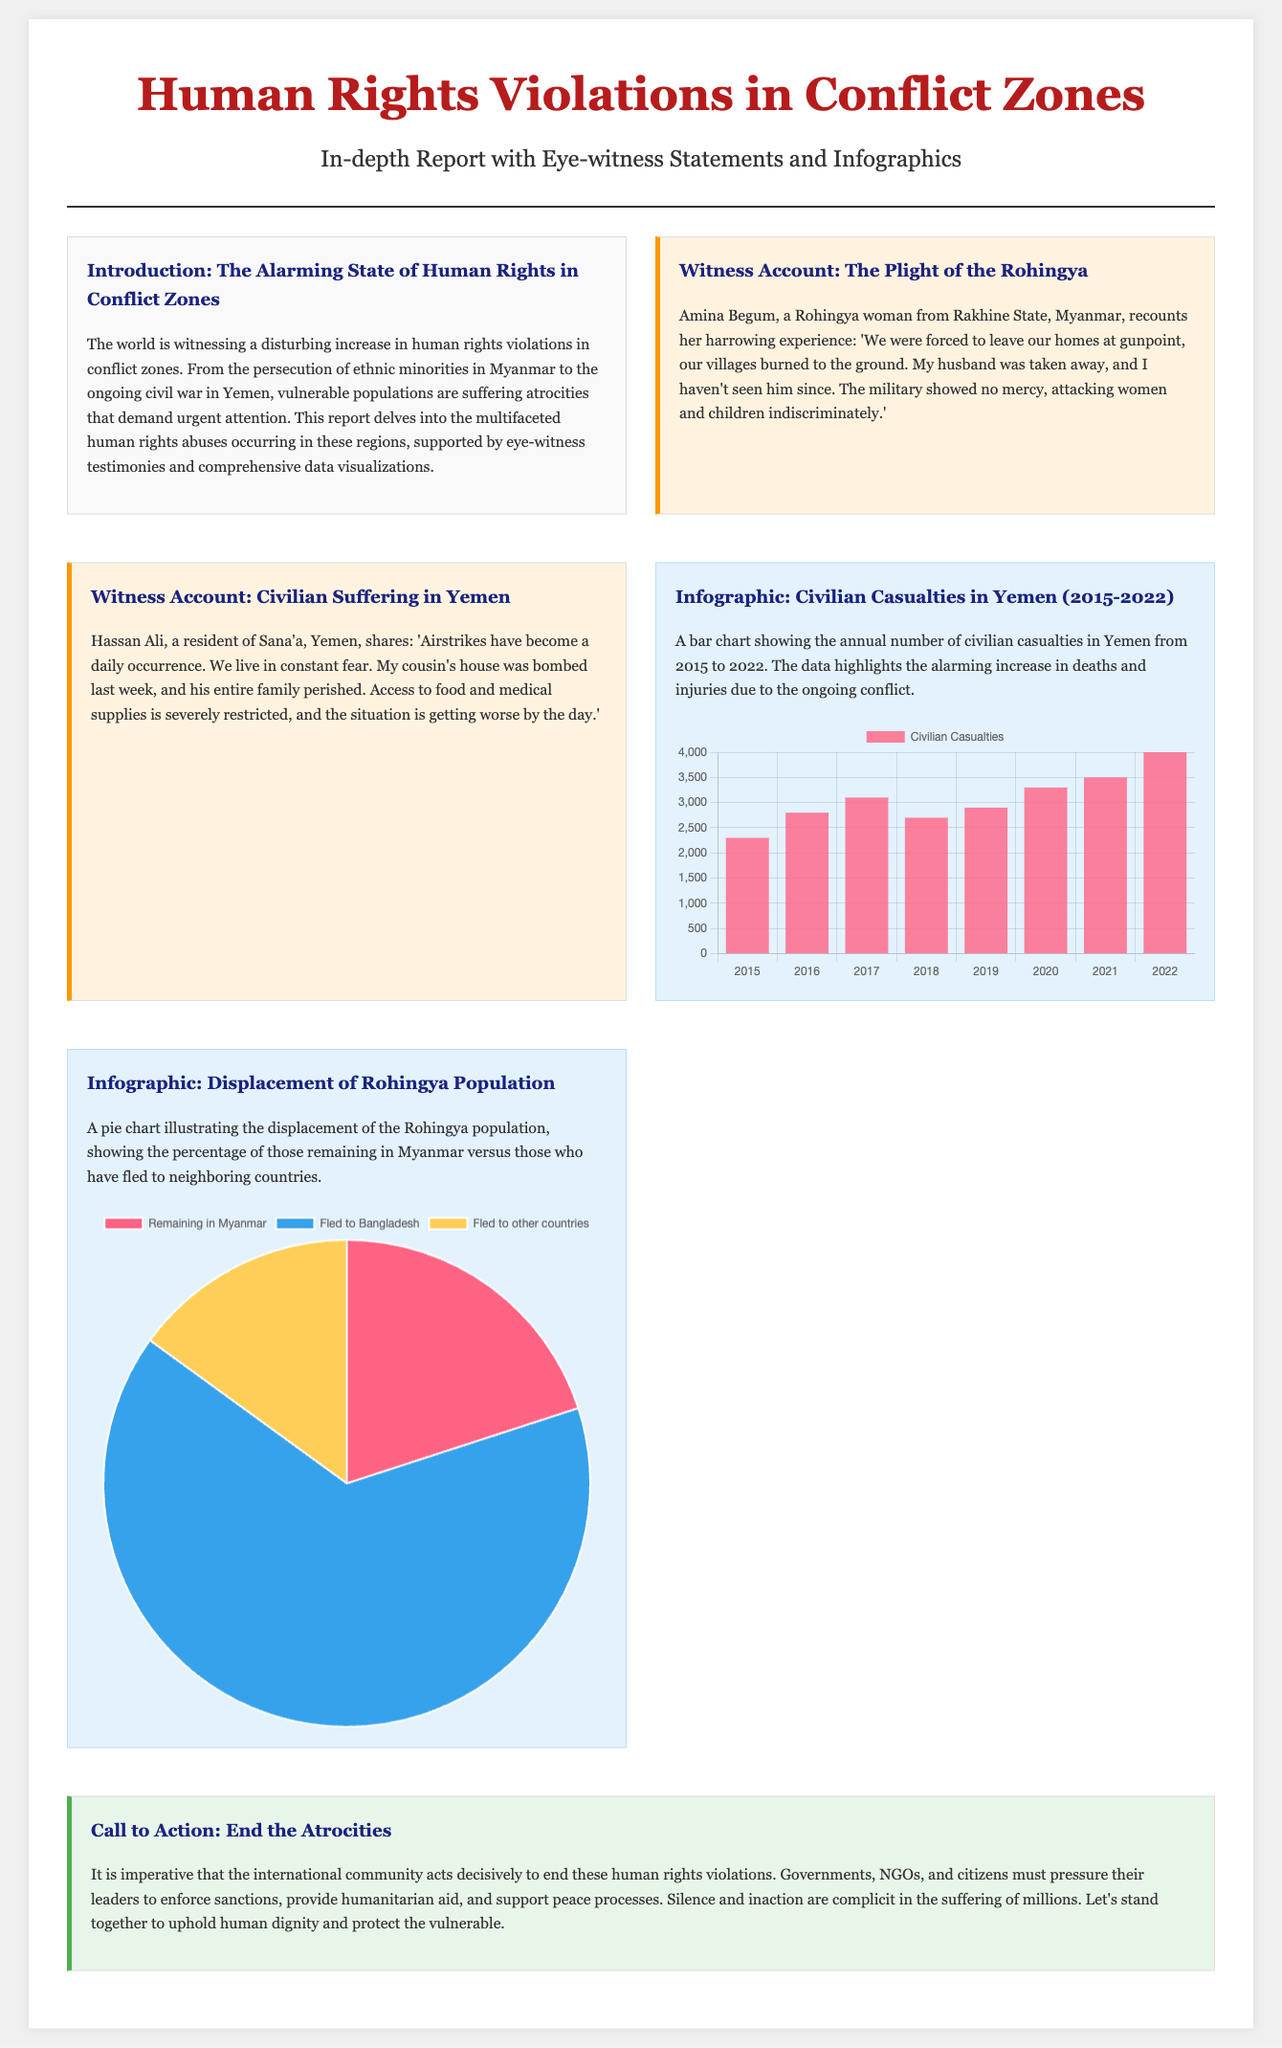What is the title of the report? The title of the report is presented prominently at the top of the document.
Answer: Human Rights Violations in Conflict Zones Who is the witness from Myanmar? The document provides the name of the witness recounting her experience in Myanmar.
Answer: Amina Begum What is the primary concern highlighted in the introduction? The introduction discusses the overall situation being reported in the conflict zones.
Answer: Human rights violations How many civilian casualties were reported in Yemen in 2022? The bar chart in the infographic provides the specific figure for civilian casualties in this year.
Answer: 4000 What percentage of the Rohingya population has fled to Bangladesh? The pie chart in the infographic illustrates the percentage of the displaced population.
Answer: 65 What color is used to represent "Fled to other countries" in the Rohingya displacement chart? The document specifies the colors used for each segment in the pie chart.
Answer: Yellow What is the main action urged in the call to action? The document expresses a specific need for action by the international community in the closing section.
Answer: End the Atrocities How many years of civilian casualties data does the Yemen infographic cover? The bar chart shows data spanning several years from its starting point to the final year mentioned.
Answer: 8 years 